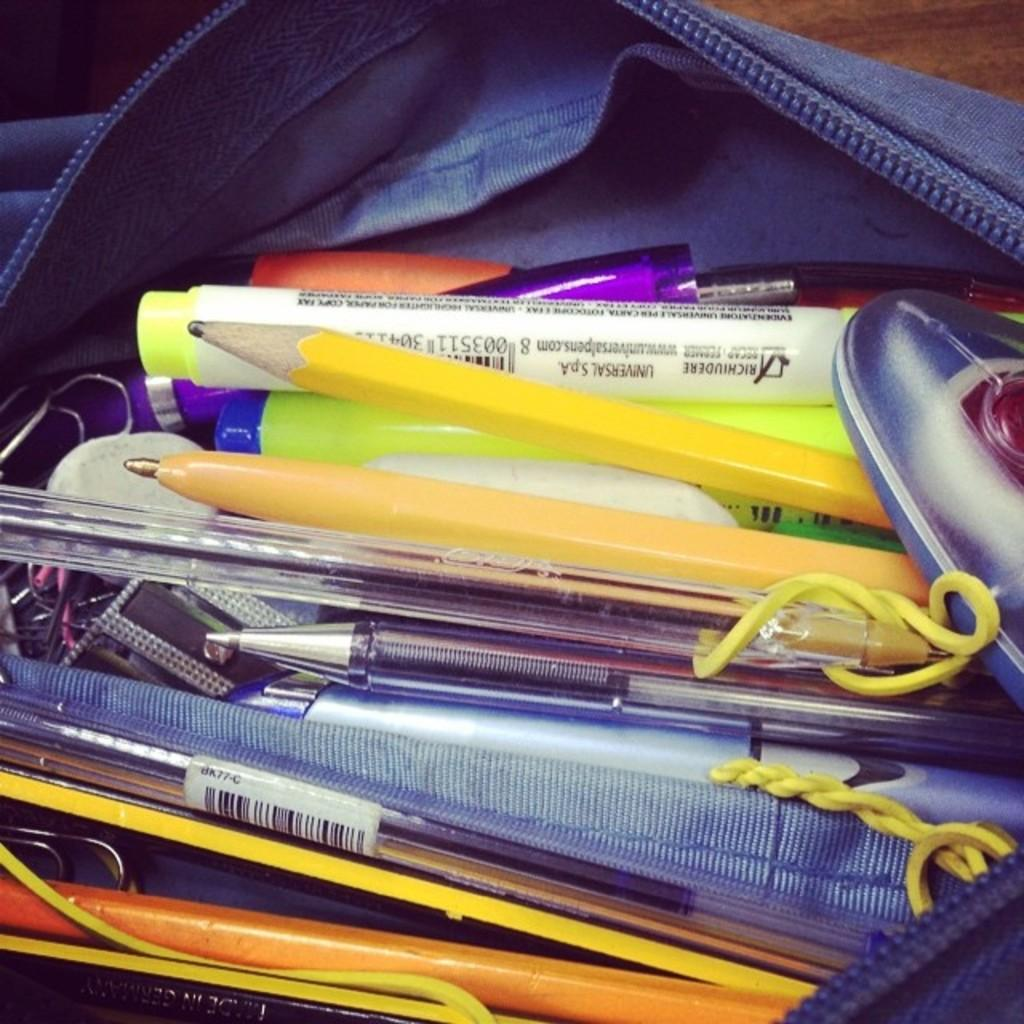What is the main object in the image? There is a pouch in the image. What items are inside the pouch? The pouch contains pens and pencils. Are there any other items in the pouch besides pens and pencils? Yes, there are other objects in the pouch. On what surface is the pouch placed? The pouch is placed on a wooden surface. What type of insect can be seen crawling on the pouch in the image? There is no insect visible on the pouch in the image. What type of police officer is standing next to the pouch in the image? There is no police officer present in the image. 